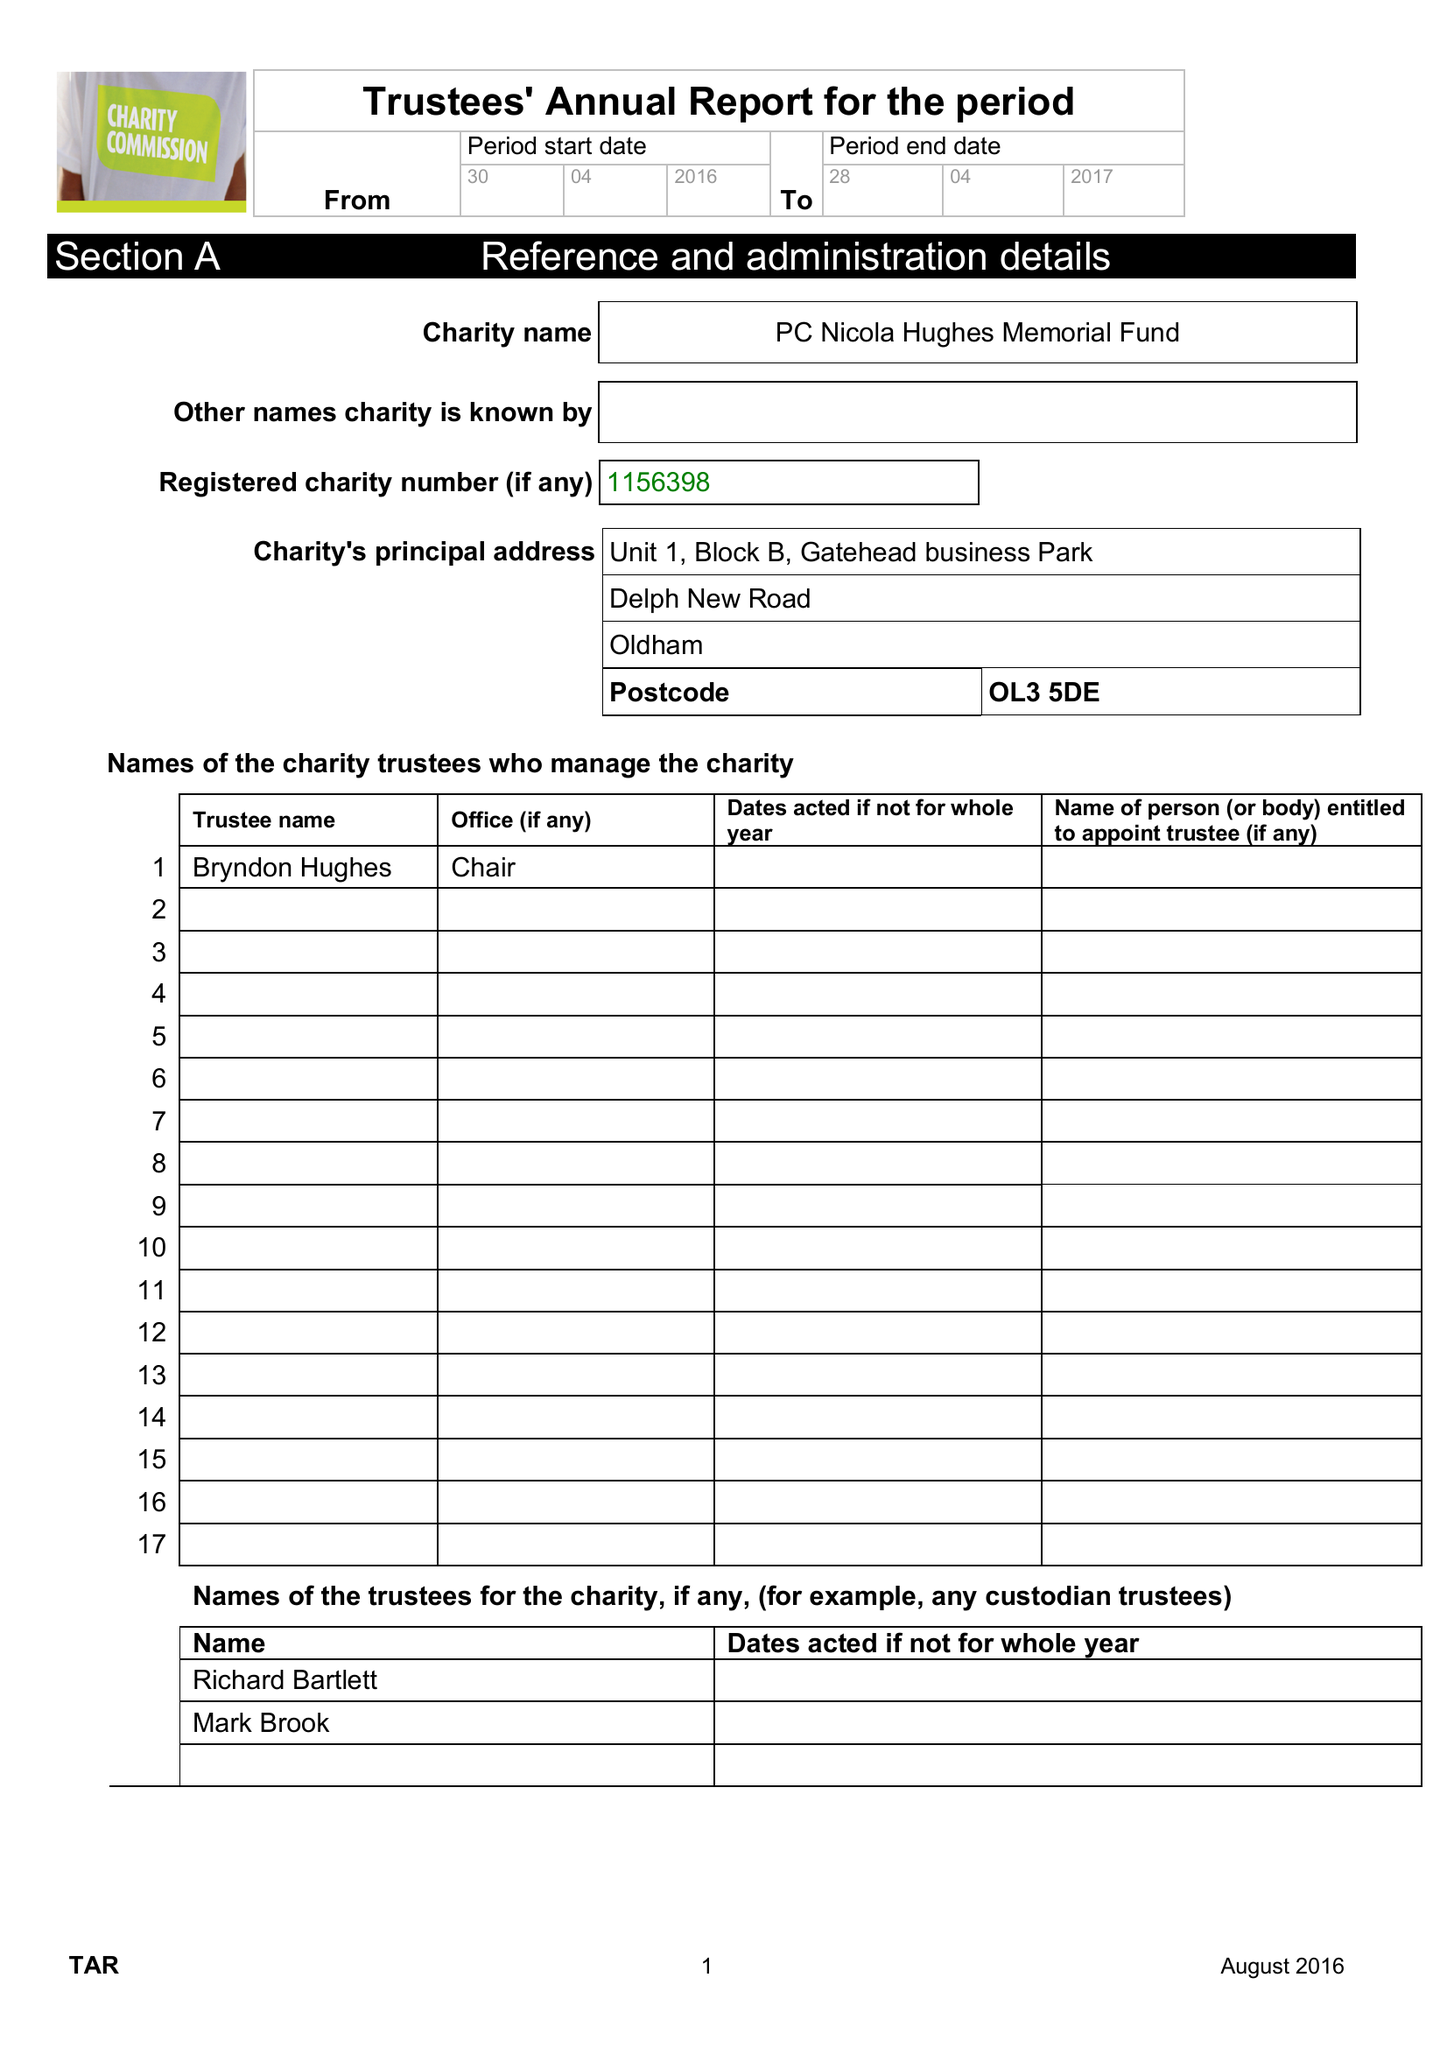What is the value for the charity_number?
Answer the question using a single word or phrase. 1156398 